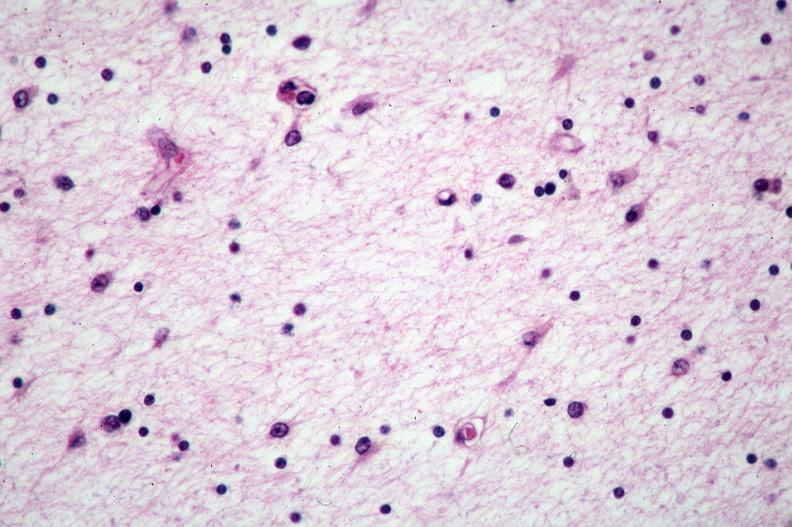what is present?
Answer the question using a single word or phrase. Nervous 